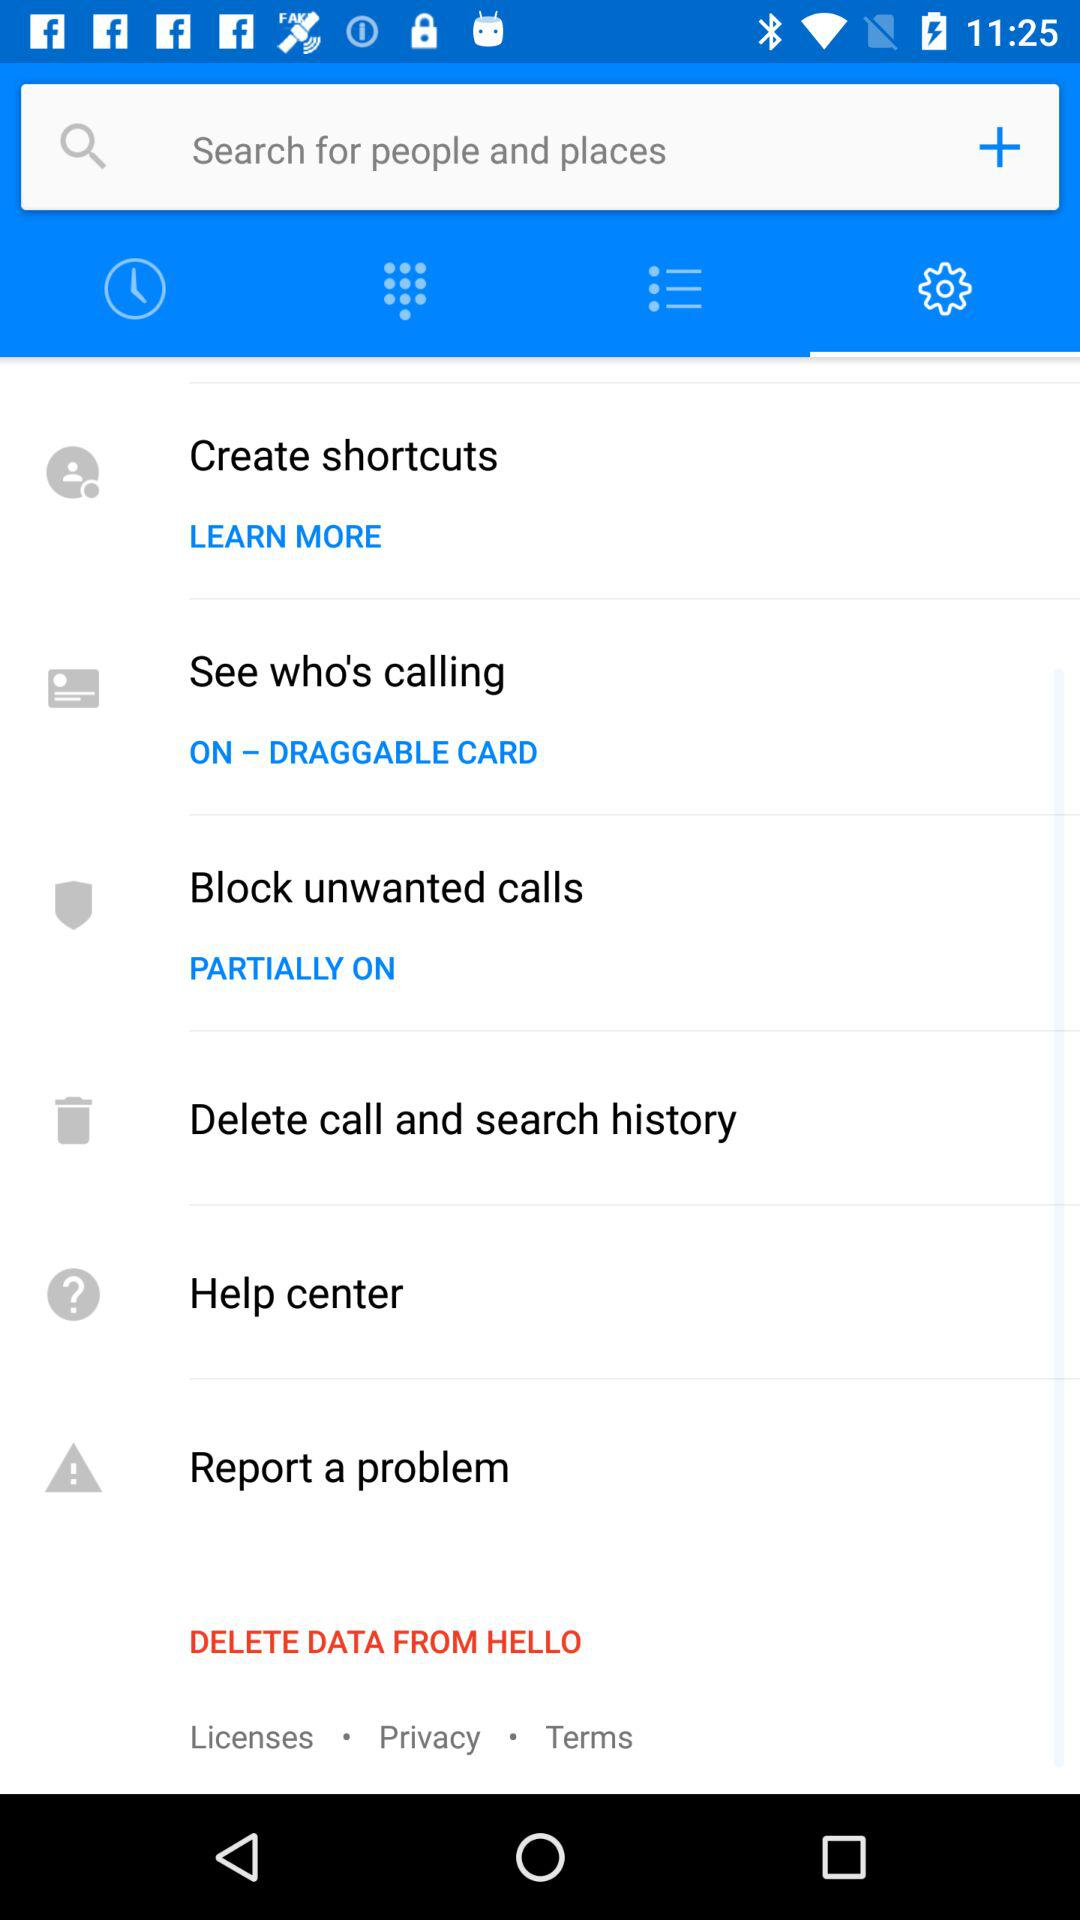How much deleted data is there?
When the provided information is insufficient, respond with <no answer>. <no answer> 